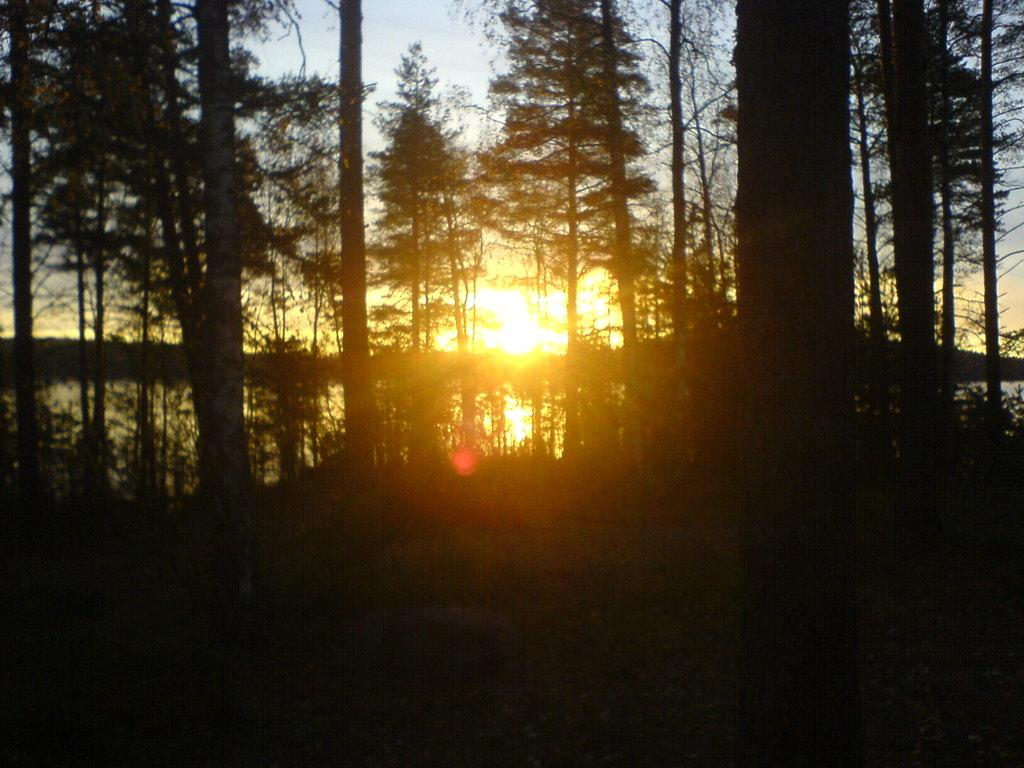What type of vegetation can be seen in the image? There are trees in the image. What natural element is visible in the image? There is water visible in the image. What is the source of light in the image? Sunlight is present in the image. What is the condition of the sky in the image? The sky is cloudy in the image. Where is the ball located in the image? There is no ball present in the image. What type of birth can be seen in the image? There is no birth depicted in the image. 